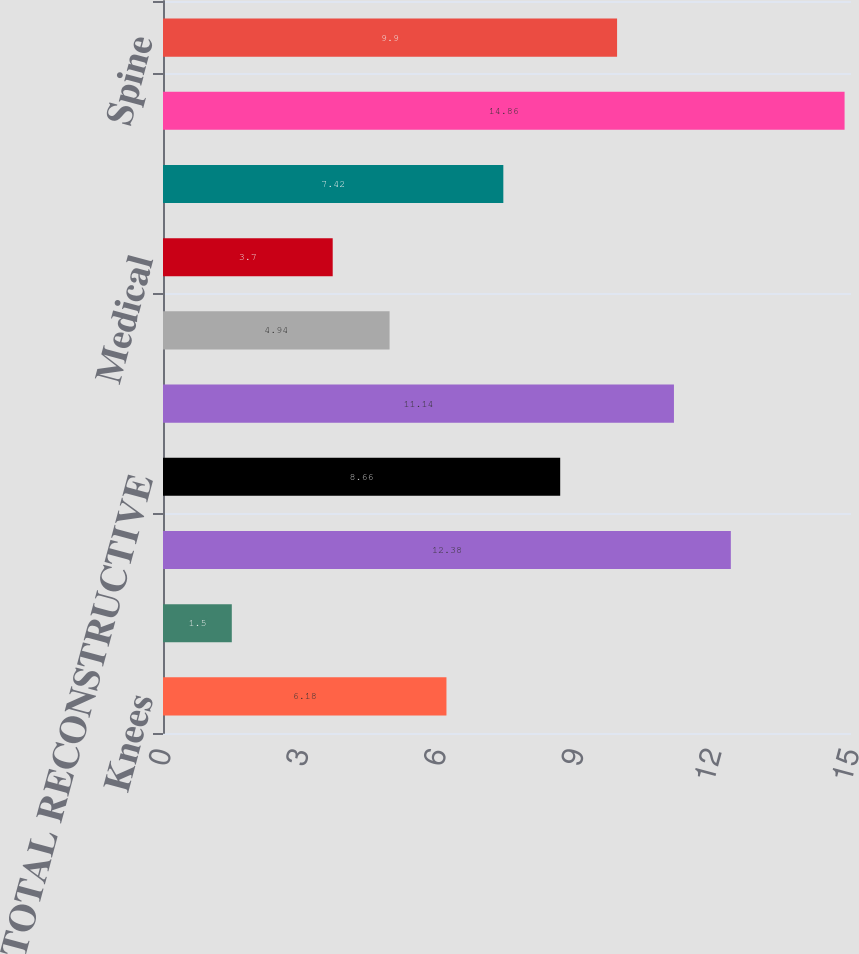Convert chart to OTSL. <chart><loc_0><loc_0><loc_500><loc_500><bar_chart><fcel>Knees<fcel>Hips<fcel>Trauma and Extremities<fcel>TOTAL RECONSTRUCTIVE<fcel>Instruments<fcel>Endoscopy<fcel>Medical<fcel>TOTAL MEDSURG<fcel>Neurotechnology<fcel>Spine<nl><fcel>6.18<fcel>1.5<fcel>12.38<fcel>8.66<fcel>11.14<fcel>4.94<fcel>3.7<fcel>7.42<fcel>14.86<fcel>9.9<nl></chart> 